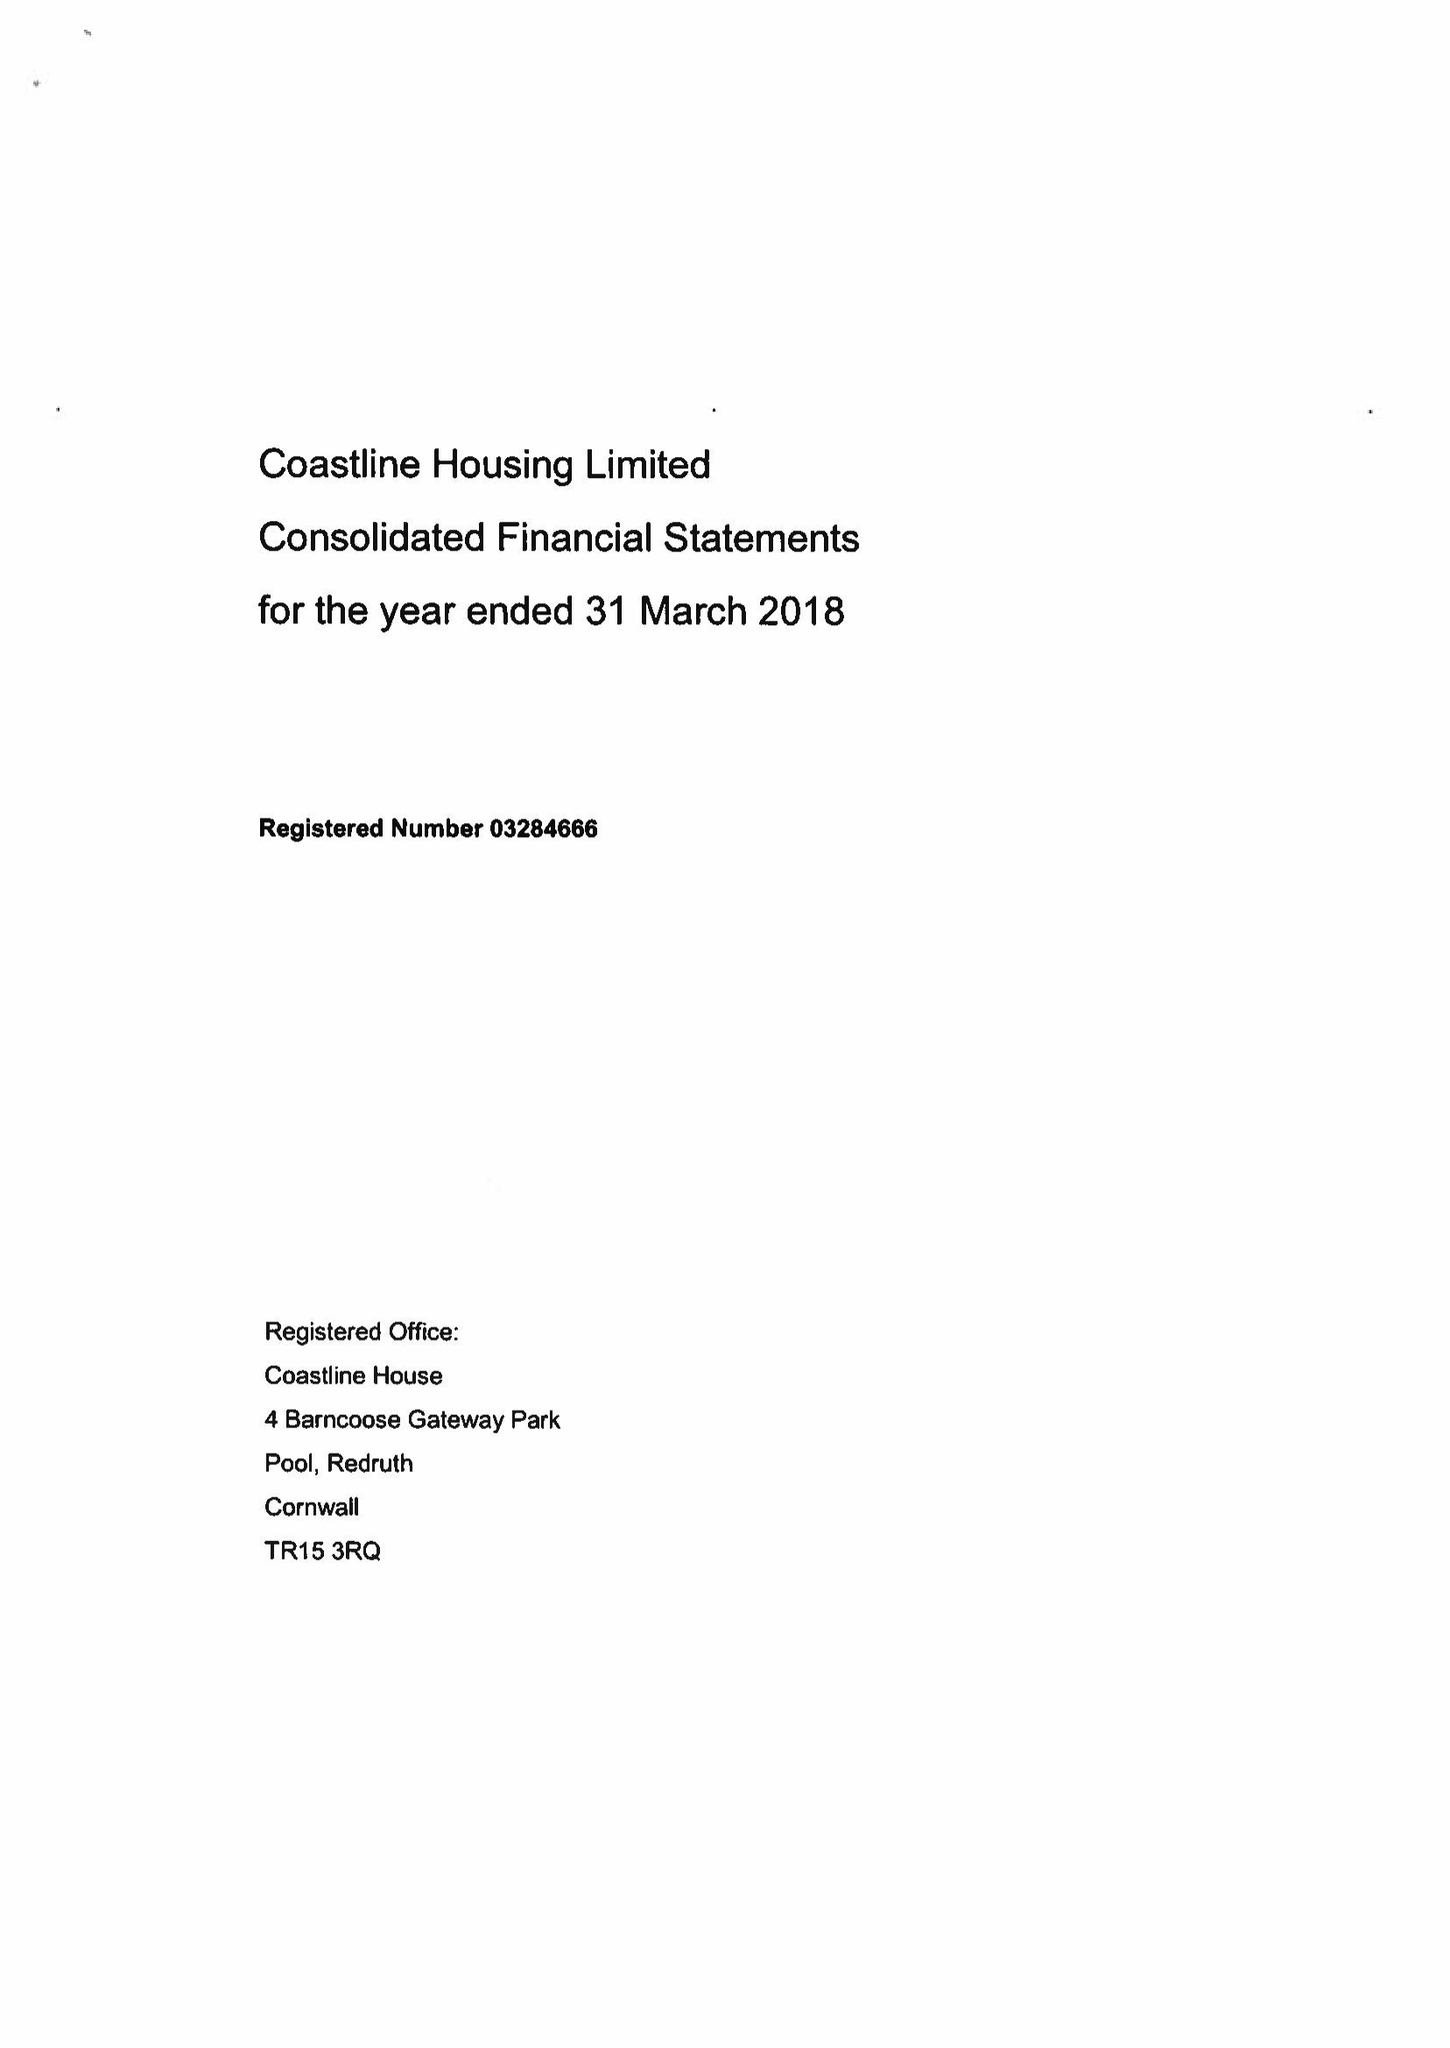What is the value for the spending_annually_in_british_pounds?
Answer the question using a single word or phrase. 24218000.00 